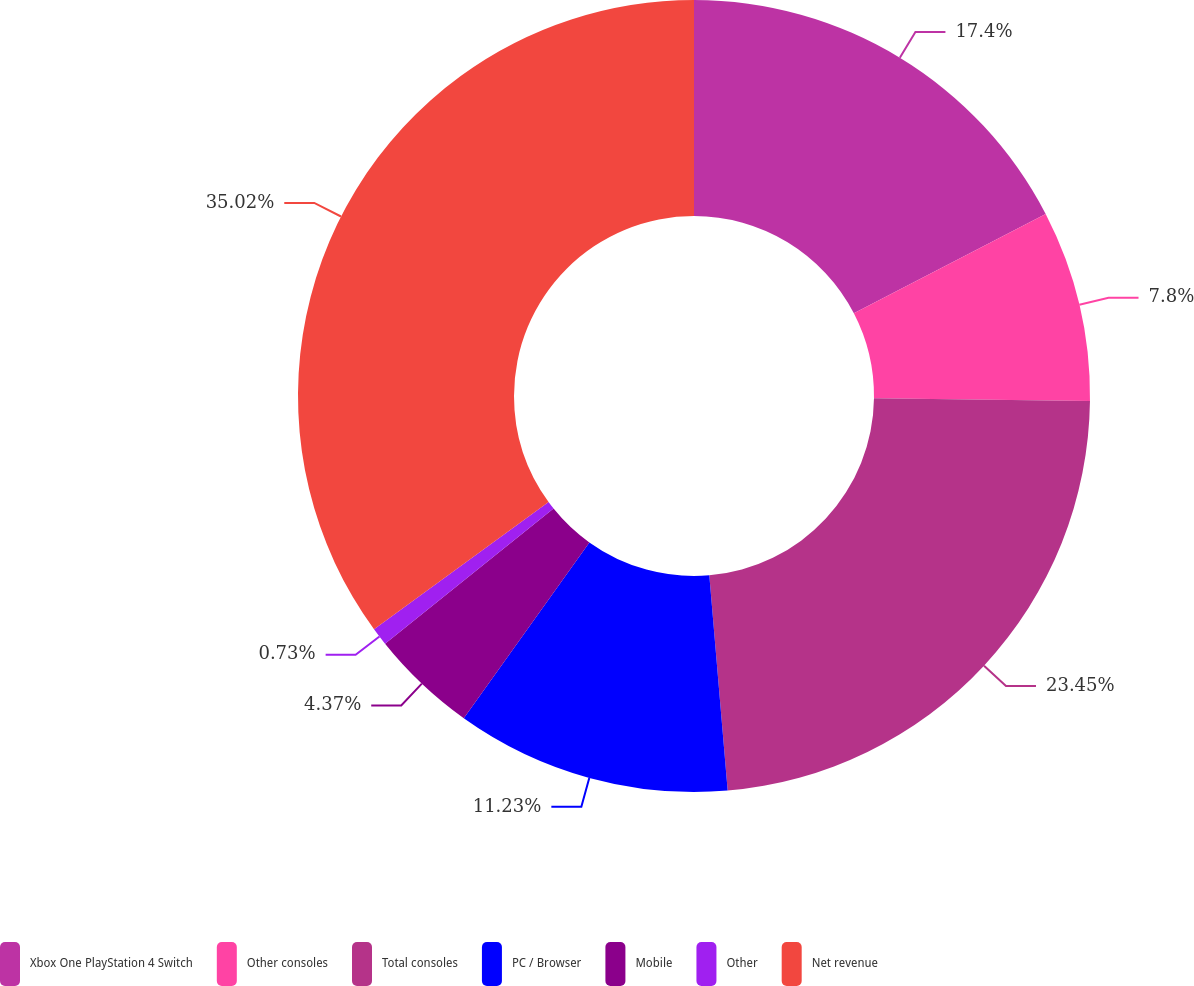Convert chart to OTSL. <chart><loc_0><loc_0><loc_500><loc_500><pie_chart><fcel>Xbox One PlayStation 4 Switch<fcel>Other consoles<fcel>Total consoles<fcel>PC / Browser<fcel>Mobile<fcel>Other<fcel>Net revenue<nl><fcel>17.4%<fcel>7.8%<fcel>23.45%<fcel>11.23%<fcel>4.37%<fcel>0.73%<fcel>35.03%<nl></chart> 